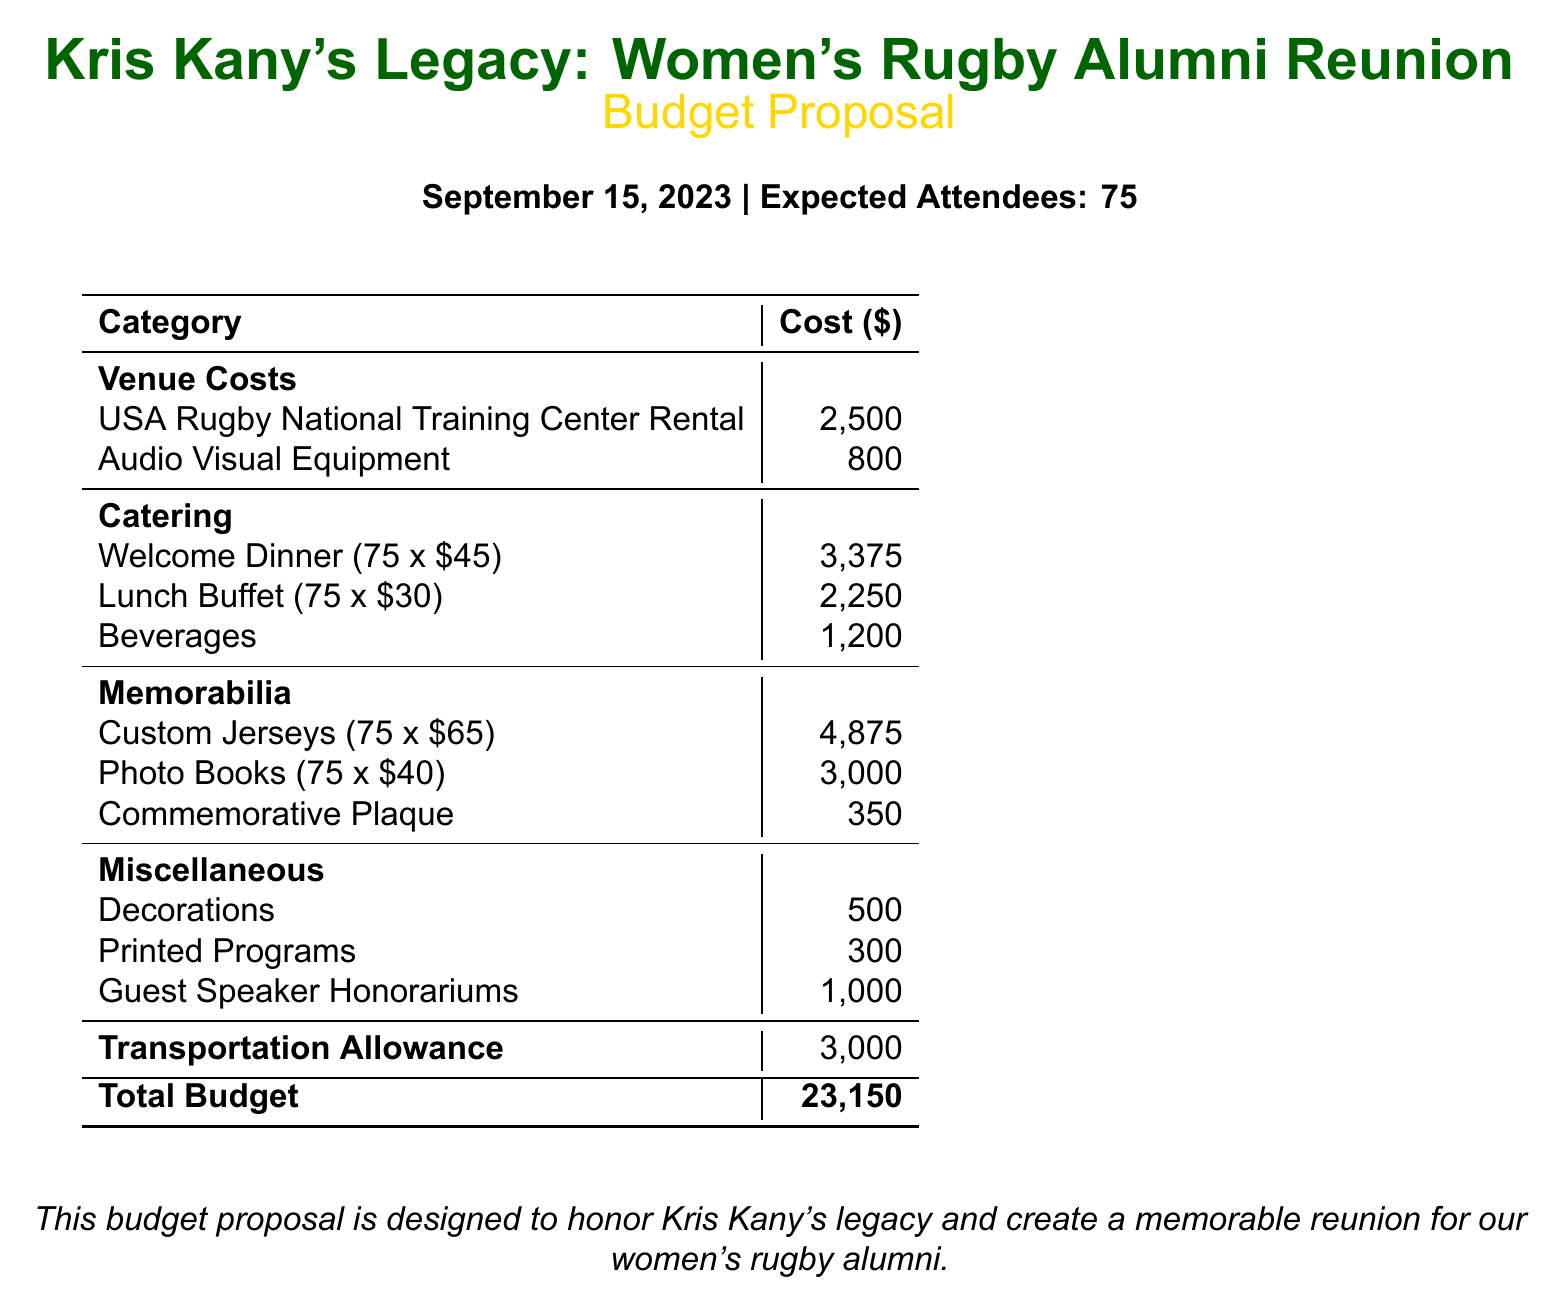What is the total budget? The total budget is clearly listed at the bottom of the document.
Answer: 23,150 How many expected attendees are there? The expected number of attendees is specified at the top of the document.
Answer: 75 What is the cost for the Welcome Dinner per person? The document states the cost per person for the Welcome Dinner in the catering section.
Answer: 45 What is the rental cost for the USA Rugby National Training Center? The rental cost is mentioned under the venue costs section of the budget.
Answer: 2,500 How much is allocated for the printed programs? The budget specifies the amount allocated for printed programs in the miscellaneous section.
Answer: 300 What is the cost for Custom Jerseys? The cost for custom jerseys is provided, based on the quantity, in the memorabilia section.
Answer: 4,875 What is the total cost for the Lunch Buffet? The document calculates the total cost for the lunch buffet based on the number of attendees and per person charge.
Answer: 2,250 How much is allocated for guest speaker honorariums? The allocation for guest speaker honorariums is stated in the miscellaneous costs of the budget.
Answer: 1,000 What is the cost for the Commemorative Plaque? The cost of the commemorative plaque is specifically mentioned under memorabilia.
Answer: 350 